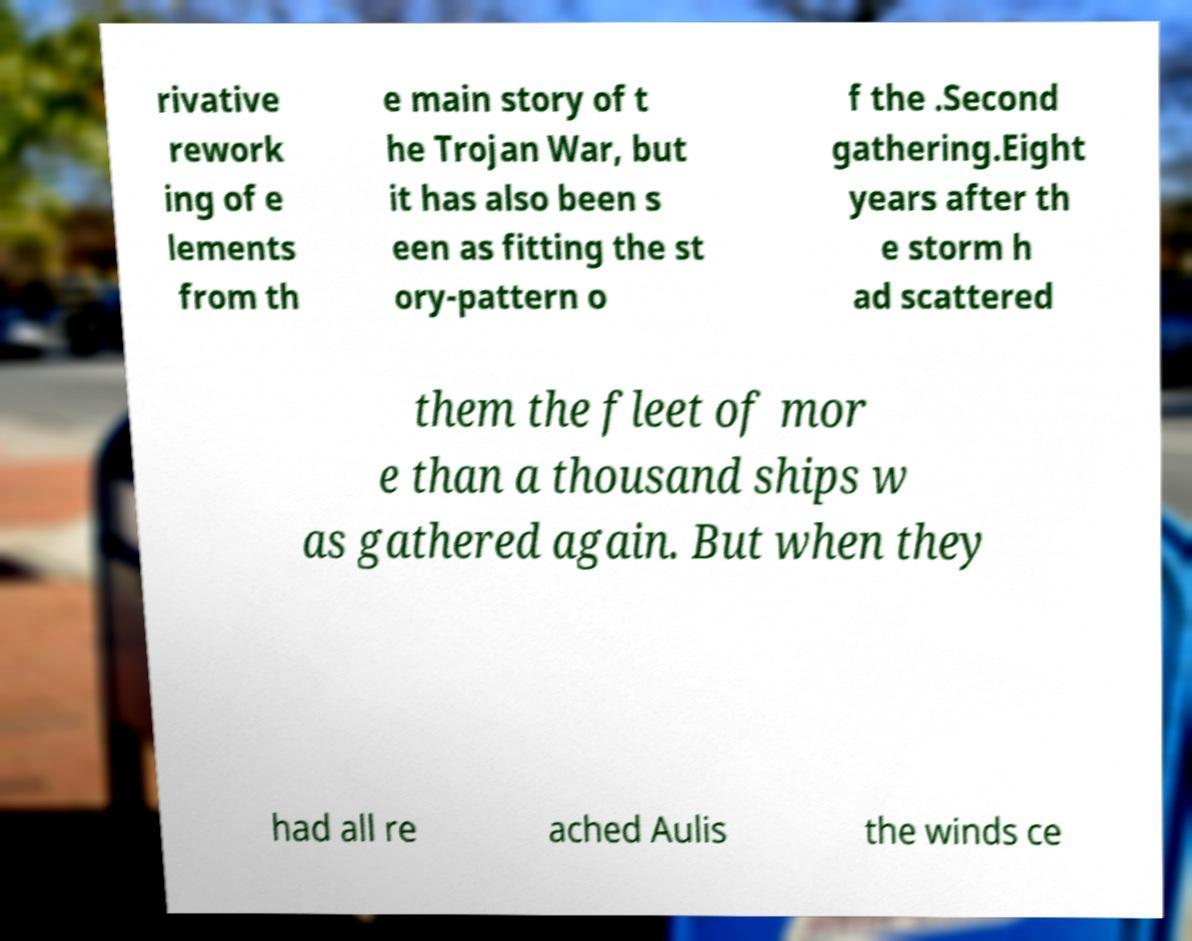What messages or text are displayed in this image? I need them in a readable, typed format. rivative rework ing of e lements from th e main story of t he Trojan War, but it has also been s een as fitting the st ory-pattern o f the .Second gathering.Eight years after th e storm h ad scattered them the fleet of mor e than a thousand ships w as gathered again. But when they had all re ached Aulis the winds ce 